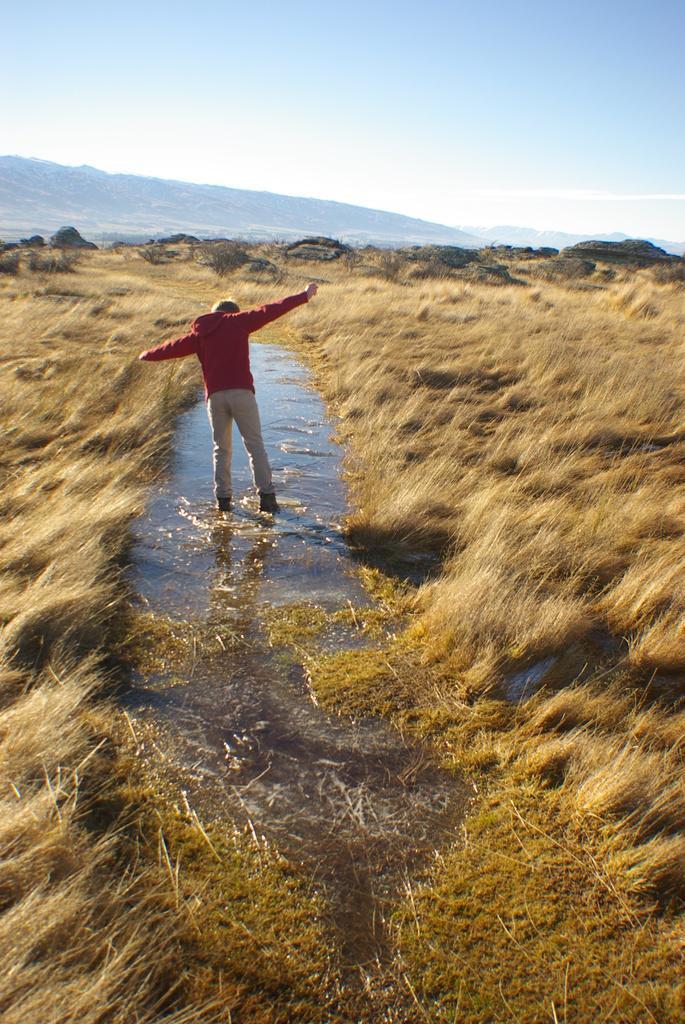Could you give a brief overview of what you see in this image? In this image, we can see a person standing in the water. Here we can see grass, mountains. Top of the image, there is a sky. 